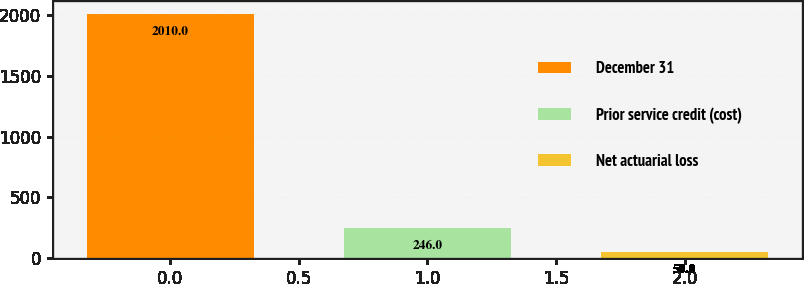<chart> <loc_0><loc_0><loc_500><loc_500><bar_chart><fcel>December 31<fcel>Prior service credit (cost)<fcel>Net actuarial loss<nl><fcel>2010<fcel>246<fcel>50<nl></chart> 